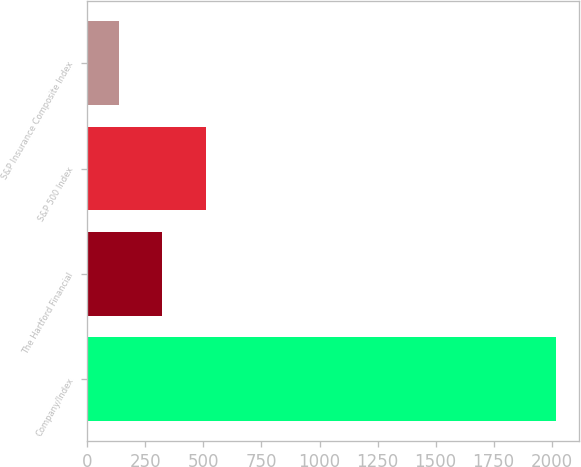<chart> <loc_0><loc_0><loc_500><loc_500><bar_chart><fcel>Company/Index<fcel>The Hartford Financial<fcel>S&P 500 Index<fcel>S&P Insurance Composite Index<nl><fcel>2018<fcel>322.78<fcel>511.14<fcel>134.42<nl></chart> 